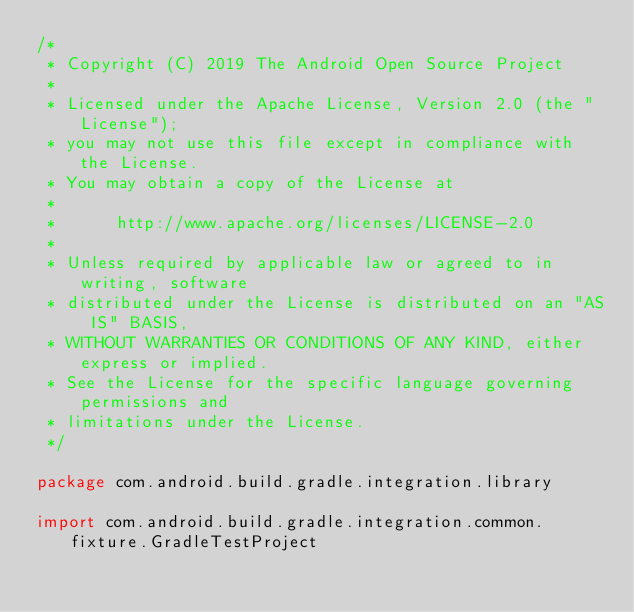Convert code to text. <code><loc_0><loc_0><loc_500><loc_500><_Kotlin_>/*
 * Copyright (C) 2019 The Android Open Source Project
 *
 * Licensed under the Apache License, Version 2.0 (the "License");
 * you may not use this file except in compliance with the License.
 * You may obtain a copy of the License at
 *
 *      http://www.apache.org/licenses/LICENSE-2.0
 *
 * Unless required by applicable law or agreed to in writing, software
 * distributed under the License is distributed on an "AS IS" BASIS,
 * WITHOUT WARRANTIES OR CONDITIONS OF ANY KIND, either express or implied.
 * See the License for the specific language governing permissions and
 * limitations under the License.
 */

package com.android.build.gradle.integration.library

import com.android.build.gradle.integration.common.fixture.GradleTestProject</code> 